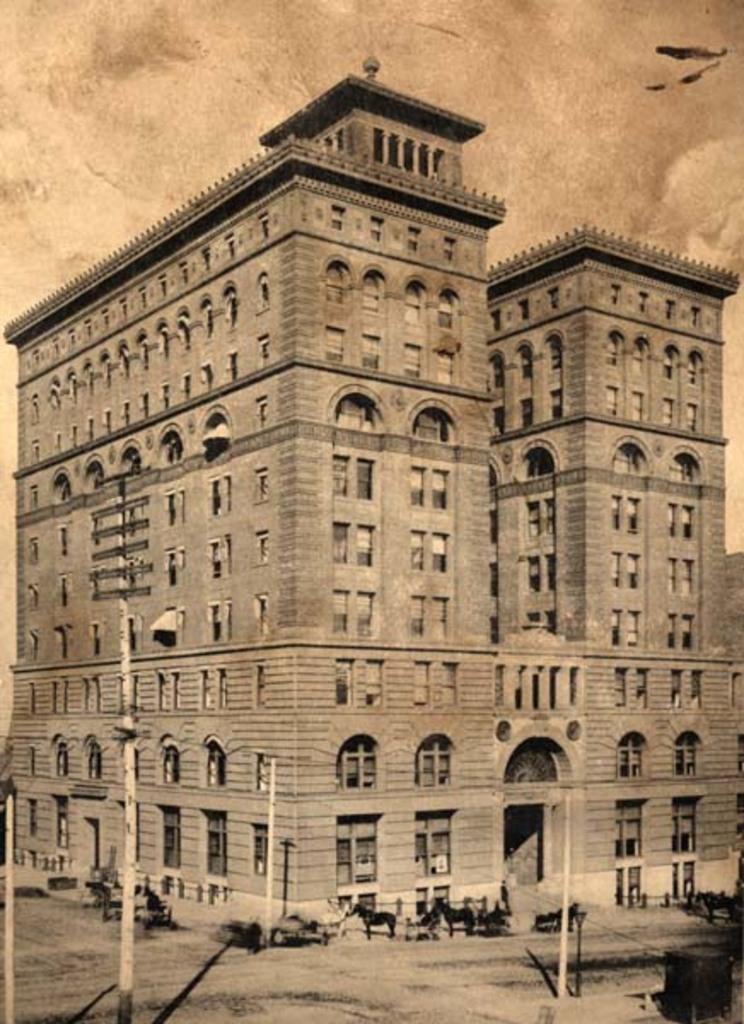How would you summarize this image in a sentence or two? This is a black and white image. In the foreground we can see the poles and we can see the group of people and a horse car and there are some objects placed on the ground. In the center we can see the building. In the background there is a sky. 